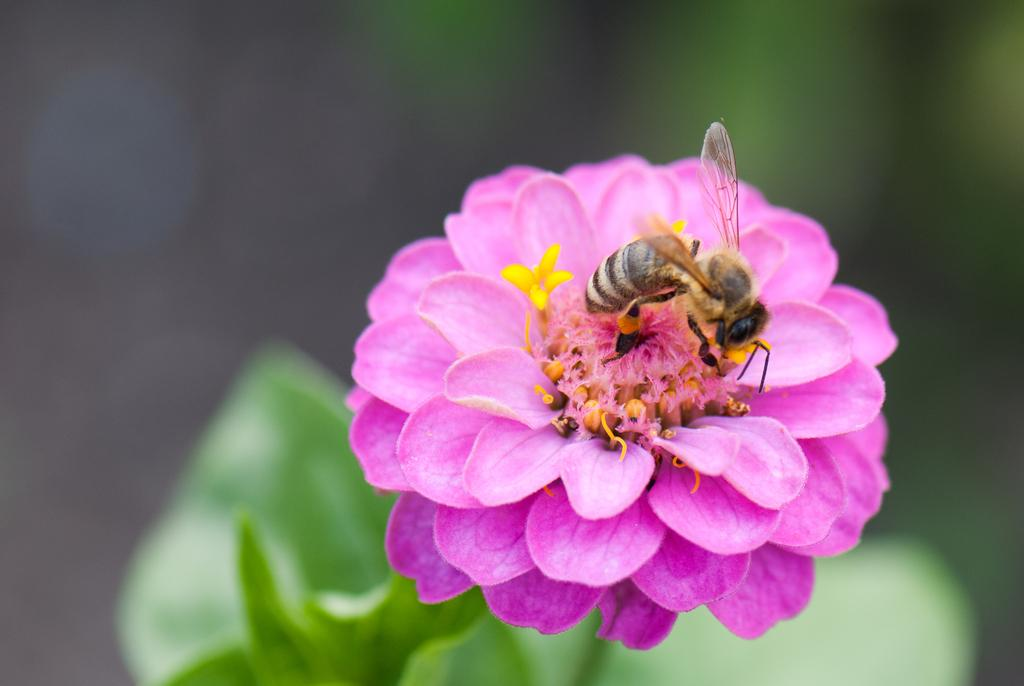What is on the flower in the image? There is a bee on a flower in the image. What color is the flower? The flower is pink. What color are the leaves of the plant? The plant has green leaves. How would you describe the background of the image? The background of the image is blurred. What is the opinion of the bee about the scale of the flower? There is no indication of the bee's opinion about the scale of the flower in the image, as bees do not have the ability to express opinions. 